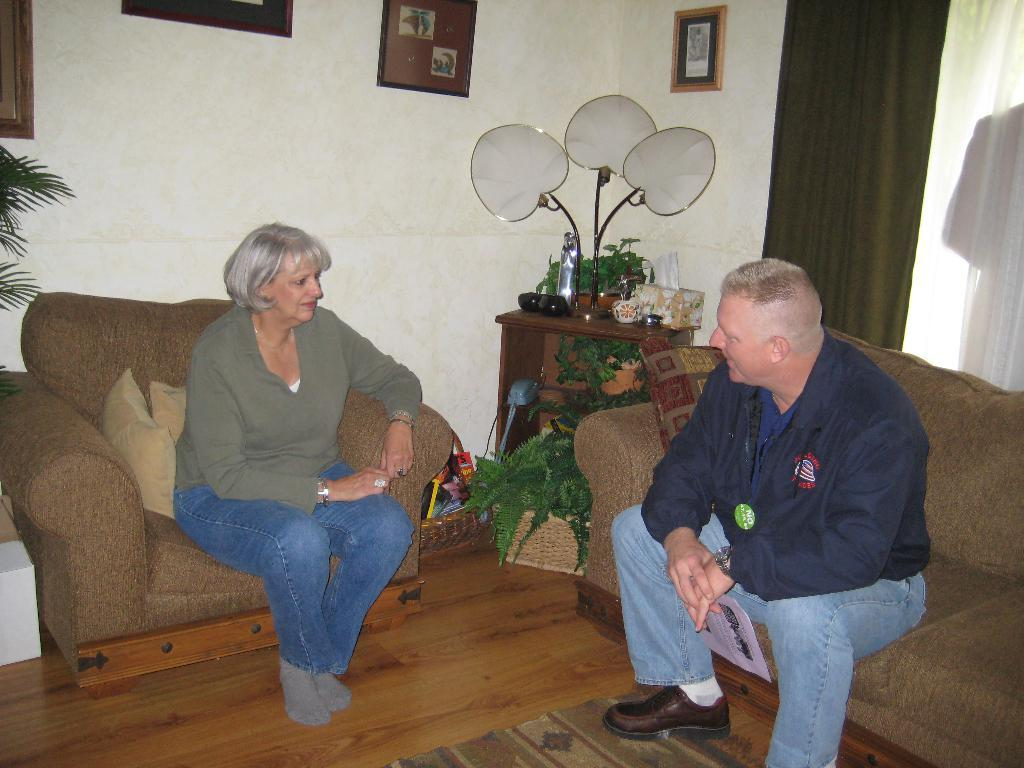What type of structure can be seen in the image? There is a wall in the image. What is hanging on the wall? There is a photo frame in the image. What type of furniture is present in the image? There are sofas in the image. How many people are in the image? There are two people in the image. What type of muscle is visible on the people in the image? There is no mention of muscles or any body parts in the provided facts, so we cannot determine if any muscles are visible in the image. 